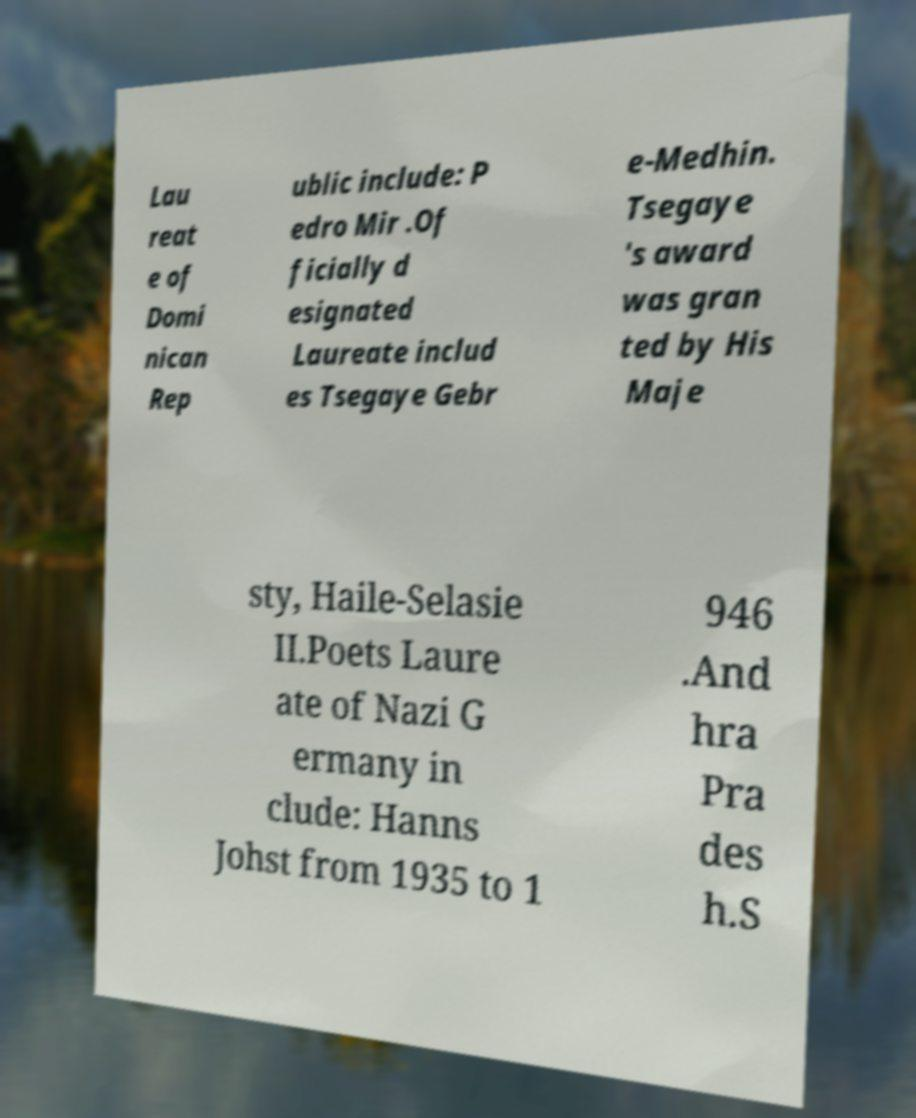What messages or text are displayed in this image? I need them in a readable, typed format. Lau reat e of Domi nican Rep ublic include: P edro Mir .Of ficially d esignated Laureate includ es Tsegaye Gebr e-Medhin. Tsegaye 's award was gran ted by His Maje sty, Haile-Selasie II.Poets Laure ate of Nazi G ermany in clude: Hanns Johst from 1935 to 1 946 .And hra Pra des h.S 